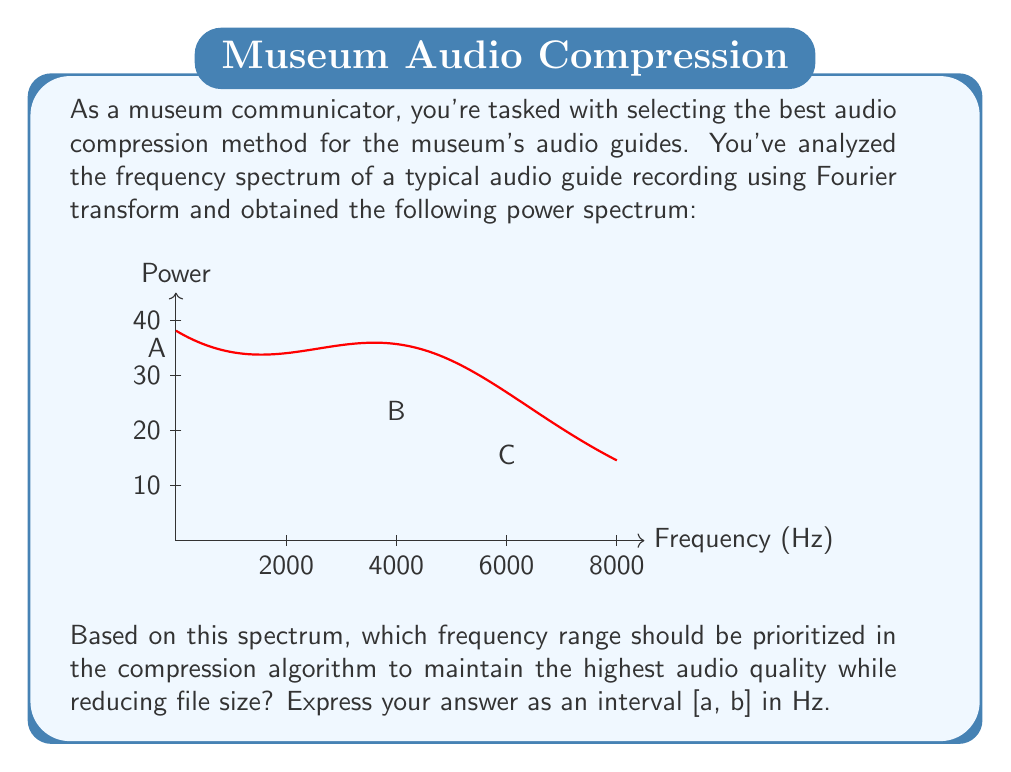Give your solution to this math problem. To determine the best frequency range for compression, we need to analyze the power spectrum:

1) The graph shows three main components:
   A: Low-frequency content (0 Hz and nearby)
   B: Mid-frequency peak around 2000 Hz
   C: High-frequency peak around 4000 Hz

2) Most of the signal's power is concentrated in the low-frequency range and the mid-frequency peak.

3) The human ear is most sensitive to frequencies between 1000 Hz and 5000 Hz, which coincides with the mid-frequency peak B and high-frequency peak C.

4) To maintain audio quality while reducing file size, we should prioritize the range that includes the low-frequency content and the mid-frequency peak.

5) The low-frequency content extends from 0 Hz to about 1000 Hz, and the mid-frequency peak is centered at 2000 Hz.

6) To capture both these important regions, we should choose a range from 0 Hz to slightly above 2000 Hz.

7) A good choice would be [0, 3000] Hz, which captures the most significant parts of the spectrum while excluding the less important high-frequency content.

This range will preserve the fundamental tones and the most audible frequencies, ensuring clear and intelligible audio guides for museum visitors.
Answer: [0, 3000] Hz 